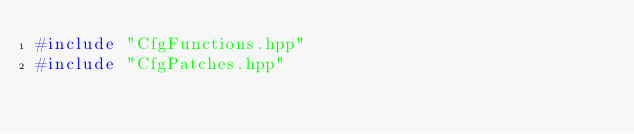Convert code to text. <code><loc_0><loc_0><loc_500><loc_500><_C++_>#include "CfgFunctions.hpp"
#include "CfgPatches.hpp"</code> 